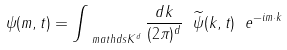<formula> <loc_0><loc_0><loc_500><loc_500>\psi ( m , t ) = \int _ { \ m a t h d s { K } ^ { d } } \frac { d k } { ( 2 \pi ) ^ { d } } \ \widetilde { \psi } ( k , t ) \ e ^ { - i m \cdot k }</formula> 